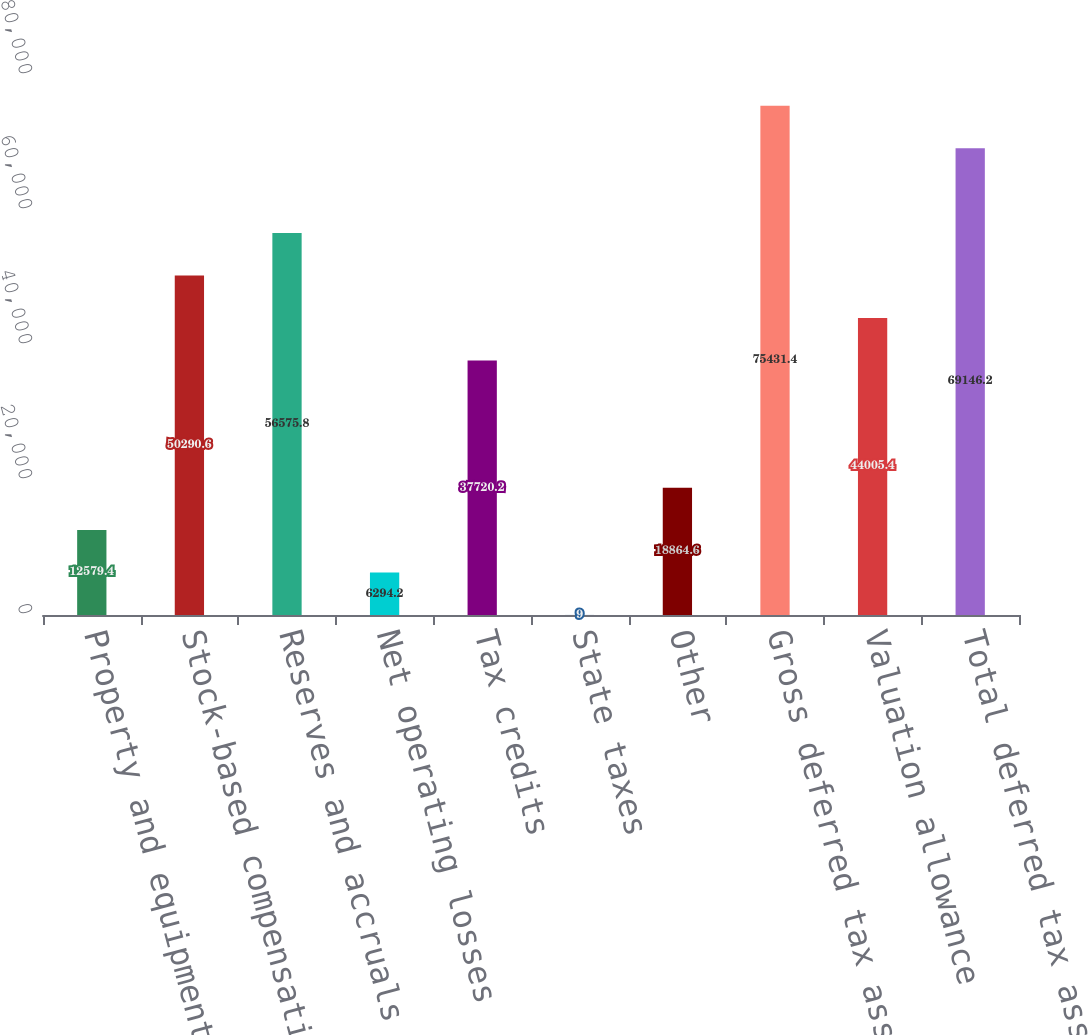Convert chart to OTSL. <chart><loc_0><loc_0><loc_500><loc_500><bar_chart><fcel>Property and equipment<fcel>Stock-based compensation<fcel>Reserves and accruals not<fcel>Net operating losses<fcel>Tax credits<fcel>State taxes<fcel>Other<fcel>Gross deferred tax assets<fcel>Valuation allowance<fcel>Total deferred tax assets<nl><fcel>12579.4<fcel>50290.6<fcel>56575.8<fcel>6294.2<fcel>37720.2<fcel>9<fcel>18864.6<fcel>75431.4<fcel>44005.4<fcel>69146.2<nl></chart> 